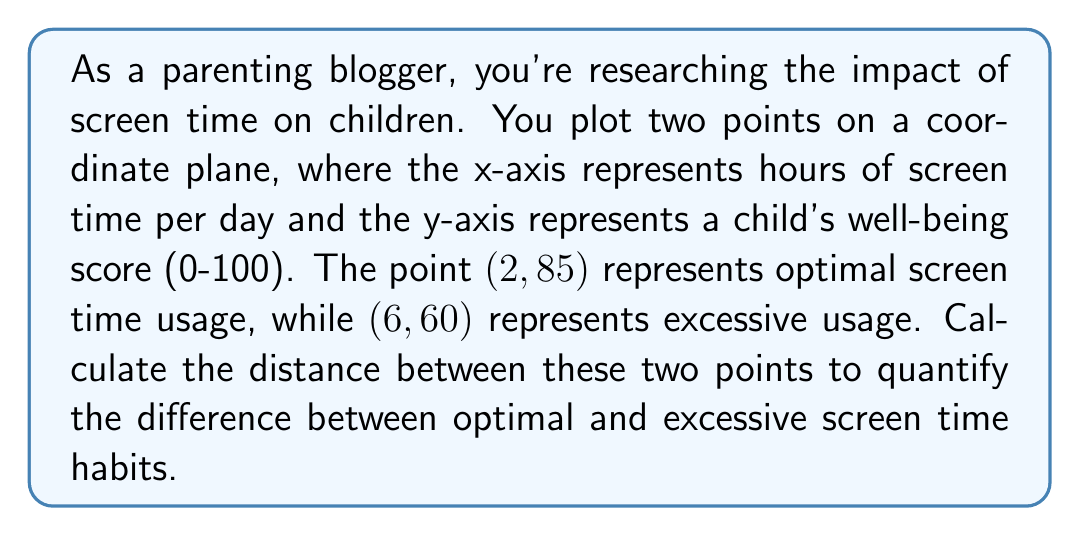Can you solve this math problem? To solve this problem, we'll use the distance formula derived from the Pythagorean theorem:

$$d = \sqrt{(x_2 - x_1)^2 + (y_2 - y_1)^2}$$

Where $(x_1, y_1)$ is the first point and $(x_2, y_2)$ is the second point.

Let's identify our points:
$(x_1, y_1) = (2, 85)$ (optimal screen time)
$(x_2, y_2) = (6, 60)$ (excessive screen time)

Now, let's substitute these values into the formula:

$$\begin{align*}
d &= \sqrt{(6 - 2)^2 + (60 - 85)^2} \\
&= \sqrt{4^2 + (-25)^2} \\
&= \sqrt{16 + 625} \\
&= \sqrt{641} \\
&\approx 25.32
\end{align*}$$

[asy]
unitsize(15);
draw((-1,0)--(8,0),arrow=Arrow(TeXHead));
draw((0,-1)--(0,100),arrow=Arrow(TeXHead));
label("Hours of screen time", (8,0), E);
label("Well-being score", (0,100), N);
dot((2,85));
dot((6,60));
label("(2, 85)", (2,85), NE);
label("(6, 60)", (6,60), SE);
draw((2,85)--(6,60),dashed);
[/asy]

The distance between the two points is approximately 25.32 units. In the context of our graph, this represents a significant difference in a child's well-being score (25 points) associated with a 4-hour increase in daily screen time.
Answer: $25.32$ (rounded to two decimal places) 